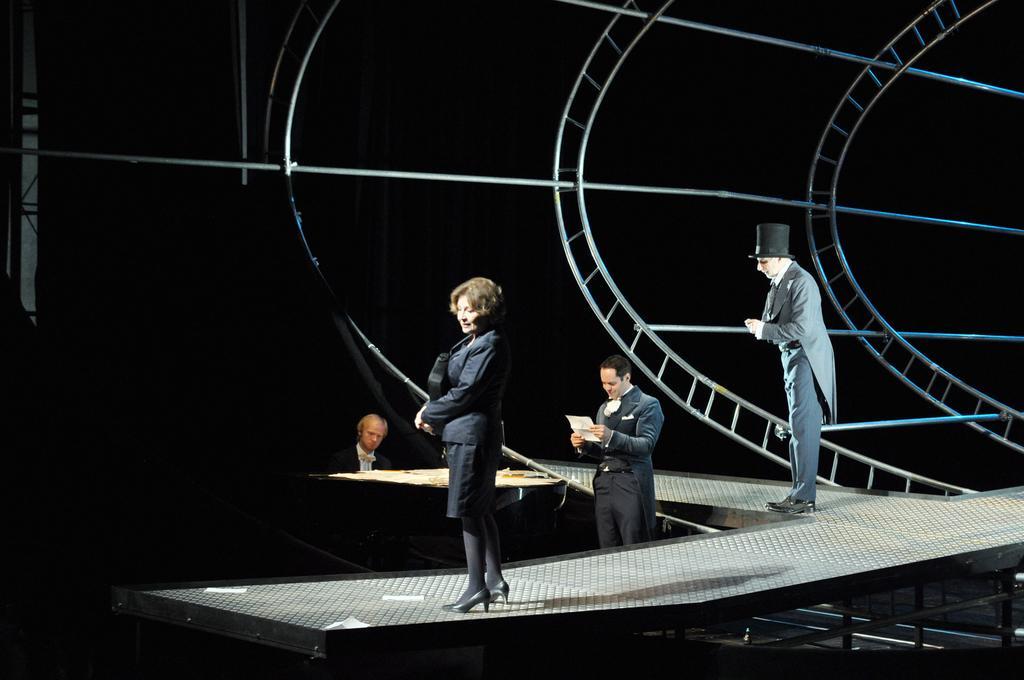In one or two sentences, can you explain what this image depicts? In this image there are persons standing and there is a person sitting, there are metal objects and there is a curtain which is black in colour. The woman standing in the center is smiling, the person standing is holding a paper in his hand and smiling and there is a person standing and wearing a hat which is black in colour and there is an object which is white and black in colour. 